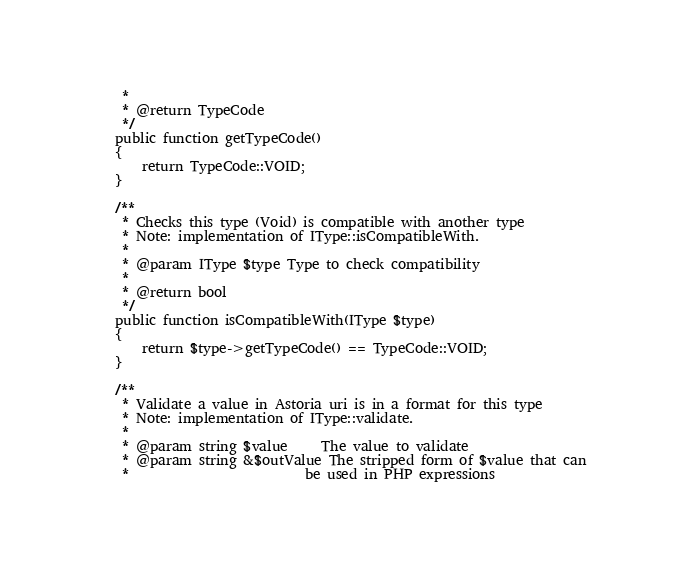Convert code to text. <code><loc_0><loc_0><loc_500><loc_500><_PHP_>     *
     * @return TypeCode
     */
    public function getTypeCode()
    {
        return TypeCode::VOID;
    }

    /**
     * Checks this type (Void) is compatible with another type
     * Note: implementation of IType::isCompatibleWith.
     *
     * @param IType $type Type to check compatibility
     *
     * @return bool
     */
    public function isCompatibleWith(IType $type)
    {
        return $type->getTypeCode() == TypeCode::VOID;
    }

    /**
     * Validate a value in Astoria uri is in a format for this type
     * Note: implementation of IType::validate.
     *
     * @param string $value     The value to validate
     * @param string &$outValue The stripped form of $value that can
     *                          be used in PHP expressions</code> 